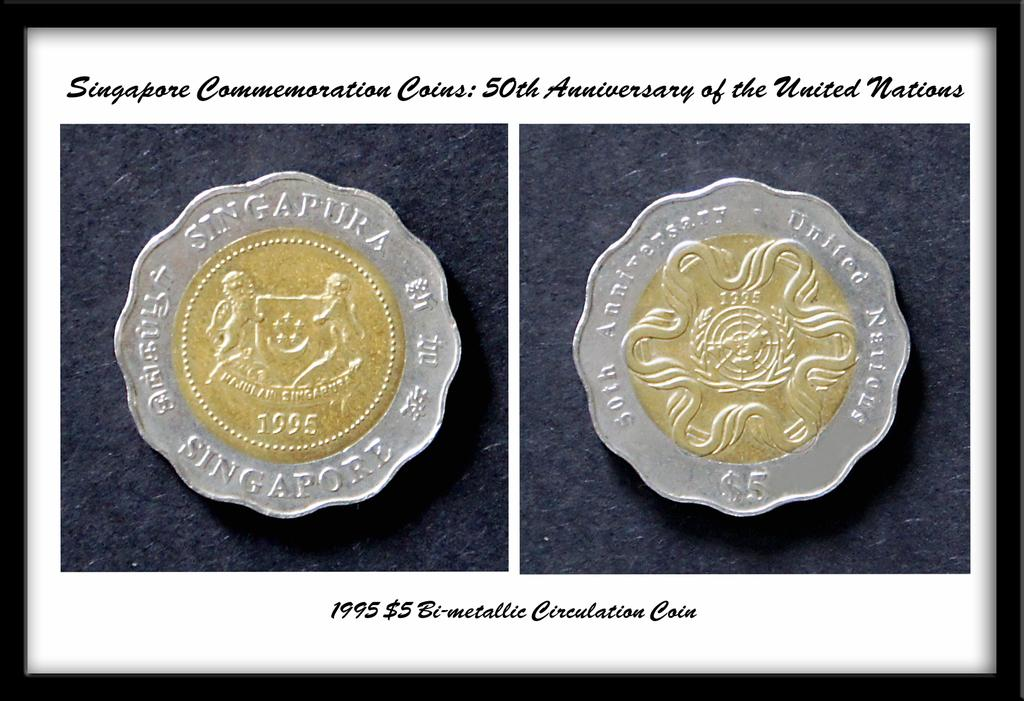What type of objects are depicted in the images within the picture? There are images of coins in the picture. What can be seen at the top of the picture? There is text at the top of the picture. What can be seen at the bottom of the picture? There is text at the bottom of the picture. How is the picture displayed? The image appears to be in a photo frame. What type of chin can be seen in the picture? There is no chin present in the picture; it features images of coins and text. 